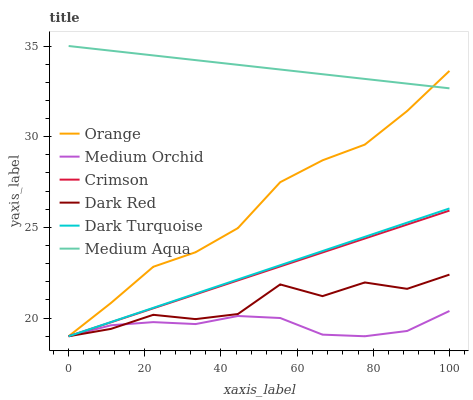Does Crimson have the minimum area under the curve?
Answer yes or no. No. Does Crimson have the maximum area under the curve?
Answer yes or no. No. Is Medium Orchid the smoothest?
Answer yes or no. No. Is Medium Orchid the roughest?
Answer yes or no. No. Does Medium Aqua have the lowest value?
Answer yes or no. No. Does Crimson have the highest value?
Answer yes or no. No. Is Dark Red less than Medium Aqua?
Answer yes or no. Yes. Is Medium Aqua greater than Dark Red?
Answer yes or no. Yes. Does Dark Red intersect Medium Aqua?
Answer yes or no. No. 